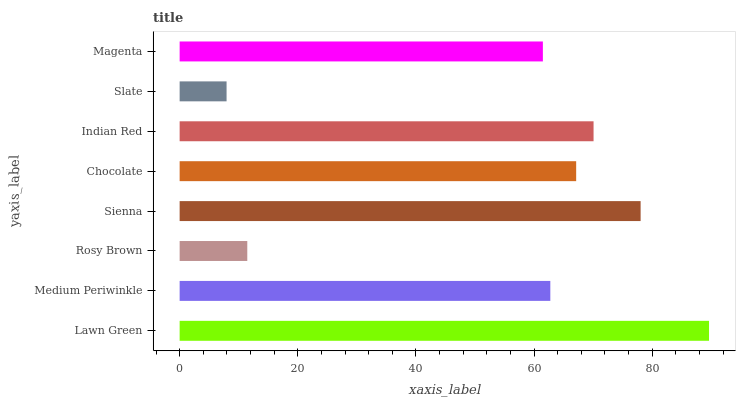Is Slate the minimum?
Answer yes or no. Yes. Is Lawn Green the maximum?
Answer yes or no. Yes. Is Medium Periwinkle the minimum?
Answer yes or no. No. Is Medium Periwinkle the maximum?
Answer yes or no. No. Is Lawn Green greater than Medium Periwinkle?
Answer yes or no. Yes. Is Medium Periwinkle less than Lawn Green?
Answer yes or no. Yes. Is Medium Periwinkle greater than Lawn Green?
Answer yes or no. No. Is Lawn Green less than Medium Periwinkle?
Answer yes or no. No. Is Chocolate the high median?
Answer yes or no. Yes. Is Medium Periwinkle the low median?
Answer yes or no. Yes. Is Medium Periwinkle the high median?
Answer yes or no. No. Is Rosy Brown the low median?
Answer yes or no. No. 